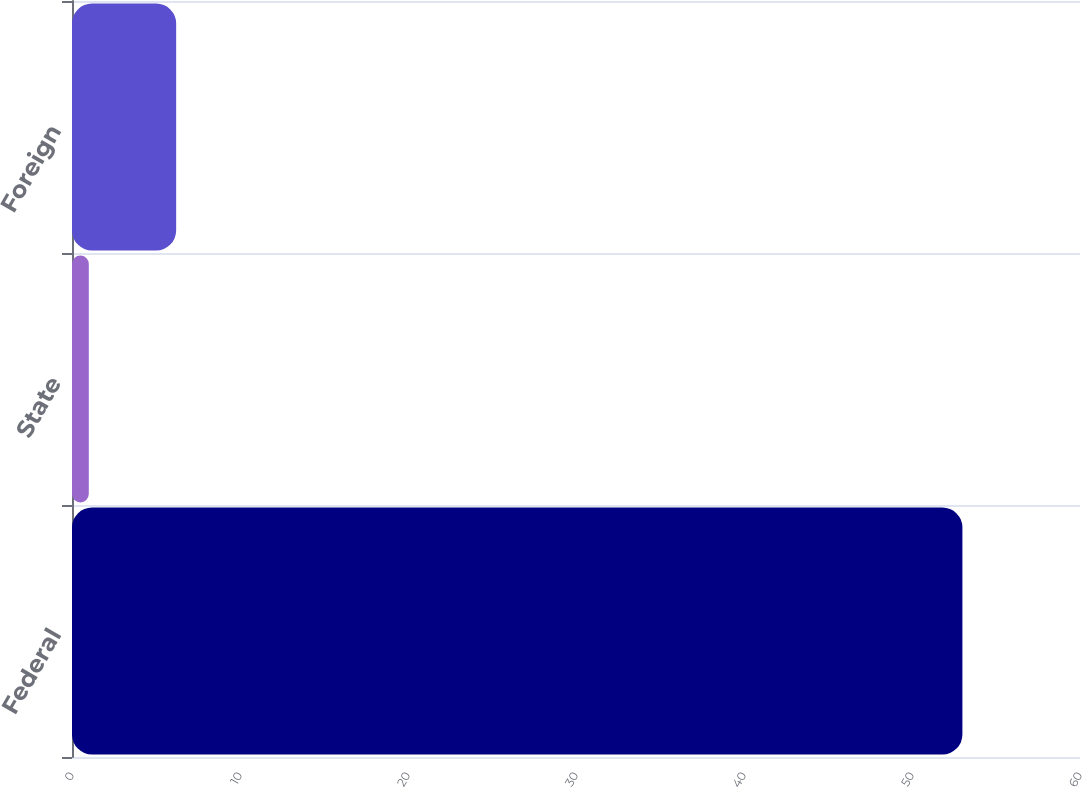<chart> <loc_0><loc_0><loc_500><loc_500><bar_chart><fcel>Federal<fcel>State<fcel>Foreign<nl><fcel>53<fcel>1<fcel>6.2<nl></chart> 